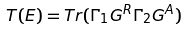<formula> <loc_0><loc_0><loc_500><loc_500>T ( E ) = T r ( \Gamma _ { 1 } G ^ { R } \Gamma _ { 2 } G ^ { A } )</formula> 